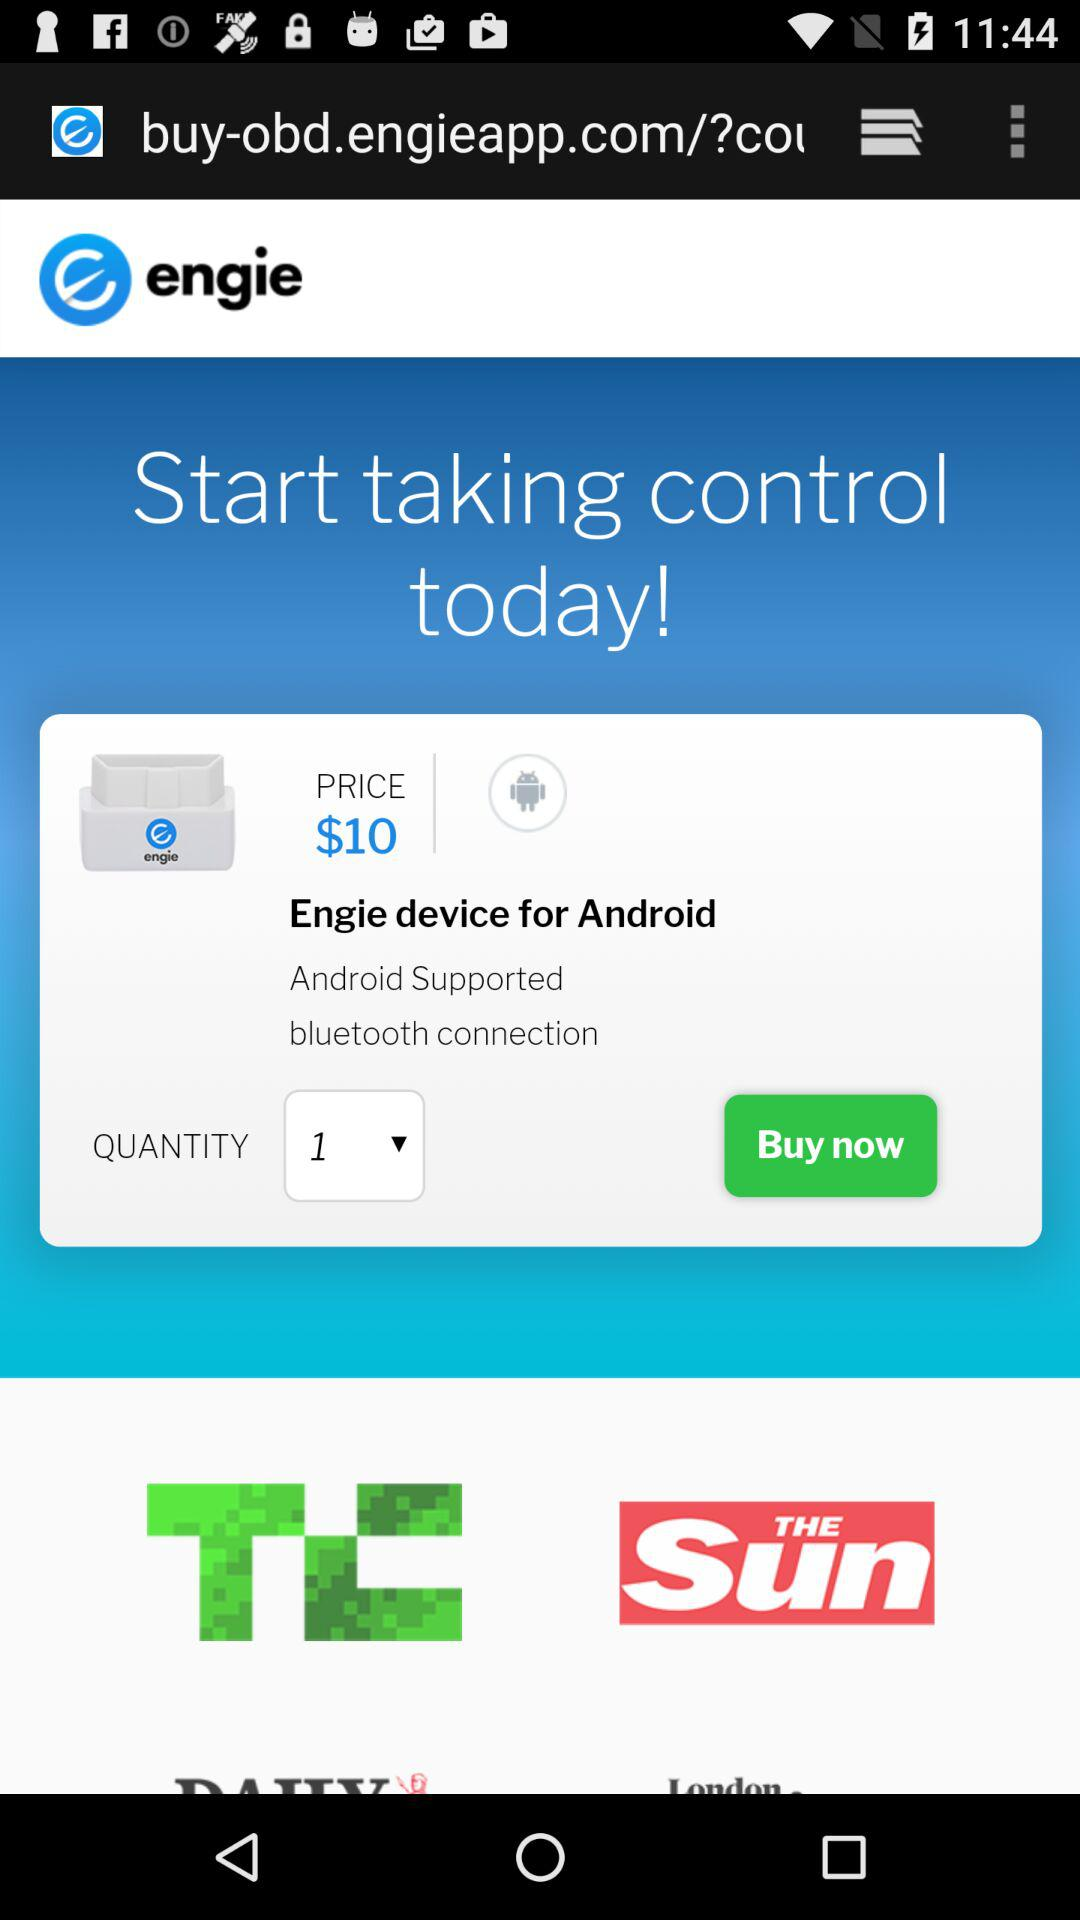What is the given device's name? The given device's name is "Engie". 